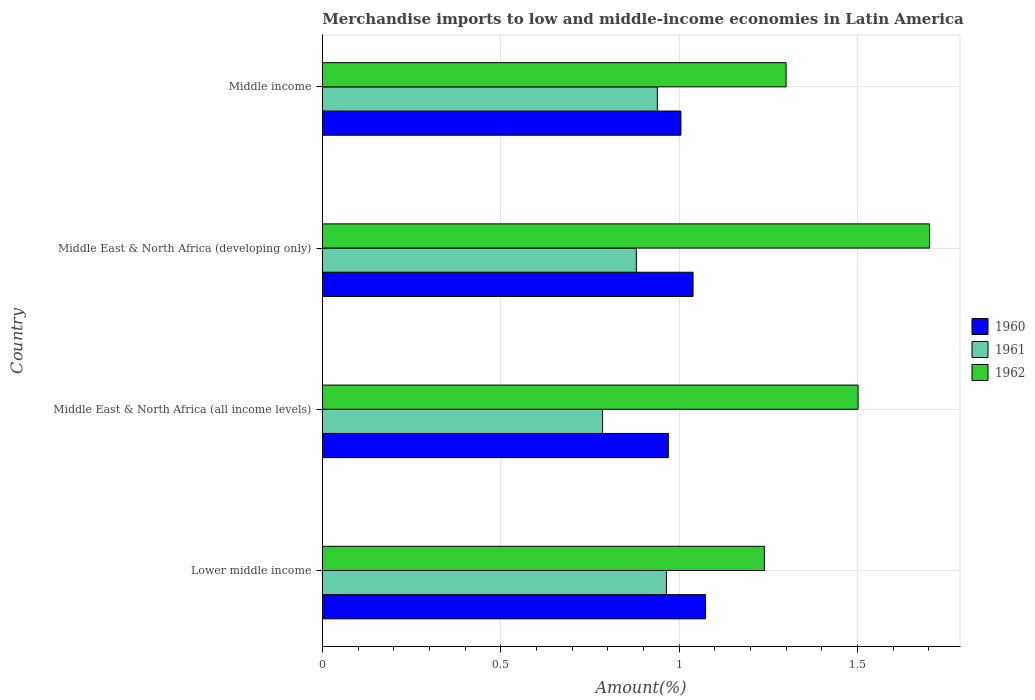Are the number of bars on each tick of the Y-axis equal?
Your answer should be compact. Yes. How many bars are there on the 2nd tick from the top?
Offer a terse response. 3. How many bars are there on the 1st tick from the bottom?
Offer a very short reply. 3. What is the label of the 4th group of bars from the top?
Keep it short and to the point. Lower middle income. What is the percentage of amount earned from merchandise imports in 1961 in Middle East & North Africa (developing only)?
Offer a very short reply. 0.88. Across all countries, what is the maximum percentage of amount earned from merchandise imports in 1960?
Your response must be concise. 1.07. Across all countries, what is the minimum percentage of amount earned from merchandise imports in 1962?
Give a very brief answer. 1.24. In which country was the percentage of amount earned from merchandise imports in 1962 maximum?
Provide a succinct answer. Middle East & North Africa (developing only). In which country was the percentage of amount earned from merchandise imports in 1960 minimum?
Your response must be concise. Middle East & North Africa (all income levels). What is the total percentage of amount earned from merchandise imports in 1961 in the graph?
Your answer should be very brief. 3.57. What is the difference between the percentage of amount earned from merchandise imports in 1960 in Middle East & North Africa (developing only) and that in Middle income?
Ensure brevity in your answer.  0.03. What is the difference between the percentage of amount earned from merchandise imports in 1961 in Middle income and the percentage of amount earned from merchandise imports in 1960 in Middle East & North Africa (developing only)?
Ensure brevity in your answer.  -0.1. What is the average percentage of amount earned from merchandise imports in 1961 per country?
Make the answer very short. 0.89. What is the difference between the percentage of amount earned from merchandise imports in 1961 and percentage of amount earned from merchandise imports in 1962 in Lower middle income?
Provide a short and direct response. -0.27. In how many countries, is the percentage of amount earned from merchandise imports in 1960 greater than 0.30000000000000004 %?
Your answer should be compact. 4. What is the ratio of the percentage of amount earned from merchandise imports in 1962 in Middle East & North Africa (developing only) to that in Middle income?
Keep it short and to the point. 1.31. Is the percentage of amount earned from merchandise imports in 1961 in Middle East & North Africa (all income levels) less than that in Middle income?
Offer a very short reply. Yes. What is the difference between the highest and the second highest percentage of amount earned from merchandise imports in 1961?
Your response must be concise. 0.03. What is the difference between the highest and the lowest percentage of amount earned from merchandise imports in 1960?
Provide a short and direct response. 0.1. In how many countries, is the percentage of amount earned from merchandise imports in 1960 greater than the average percentage of amount earned from merchandise imports in 1960 taken over all countries?
Keep it short and to the point. 2. Is the sum of the percentage of amount earned from merchandise imports in 1961 in Middle East & North Africa (developing only) and Middle income greater than the maximum percentage of amount earned from merchandise imports in 1962 across all countries?
Your response must be concise. Yes. Is it the case that in every country, the sum of the percentage of amount earned from merchandise imports in 1960 and percentage of amount earned from merchandise imports in 1961 is greater than the percentage of amount earned from merchandise imports in 1962?
Provide a succinct answer. Yes. How many bars are there?
Give a very brief answer. 12. Are all the bars in the graph horizontal?
Provide a short and direct response. Yes. How many countries are there in the graph?
Your answer should be very brief. 4. Are the values on the major ticks of X-axis written in scientific E-notation?
Ensure brevity in your answer.  No. Where does the legend appear in the graph?
Your response must be concise. Center right. How many legend labels are there?
Your answer should be very brief. 3. How are the legend labels stacked?
Offer a very short reply. Vertical. What is the title of the graph?
Your response must be concise. Merchandise imports to low and middle-income economies in Latin America. Does "1968" appear as one of the legend labels in the graph?
Provide a short and direct response. No. What is the label or title of the X-axis?
Your answer should be compact. Amount(%). What is the label or title of the Y-axis?
Offer a terse response. Country. What is the Amount(%) of 1960 in Lower middle income?
Your response must be concise. 1.07. What is the Amount(%) in 1961 in Lower middle income?
Provide a short and direct response. 0.96. What is the Amount(%) of 1962 in Lower middle income?
Offer a terse response. 1.24. What is the Amount(%) in 1960 in Middle East & North Africa (all income levels)?
Offer a terse response. 0.97. What is the Amount(%) in 1961 in Middle East & North Africa (all income levels)?
Your answer should be very brief. 0.79. What is the Amount(%) of 1962 in Middle East & North Africa (all income levels)?
Your response must be concise. 1.5. What is the Amount(%) of 1960 in Middle East & North Africa (developing only)?
Keep it short and to the point. 1.04. What is the Amount(%) of 1961 in Middle East & North Africa (developing only)?
Your answer should be very brief. 0.88. What is the Amount(%) of 1962 in Middle East & North Africa (developing only)?
Provide a short and direct response. 1.7. What is the Amount(%) of 1960 in Middle income?
Your response must be concise. 1.01. What is the Amount(%) in 1961 in Middle income?
Your response must be concise. 0.94. What is the Amount(%) of 1962 in Middle income?
Keep it short and to the point. 1.3. Across all countries, what is the maximum Amount(%) of 1960?
Your answer should be very brief. 1.07. Across all countries, what is the maximum Amount(%) in 1961?
Keep it short and to the point. 0.96. Across all countries, what is the maximum Amount(%) of 1962?
Your answer should be very brief. 1.7. Across all countries, what is the minimum Amount(%) of 1960?
Your answer should be very brief. 0.97. Across all countries, what is the minimum Amount(%) in 1961?
Provide a succinct answer. 0.79. Across all countries, what is the minimum Amount(%) of 1962?
Provide a succinct answer. 1.24. What is the total Amount(%) of 1960 in the graph?
Your response must be concise. 4.09. What is the total Amount(%) in 1961 in the graph?
Your answer should be very brief. 3.57. What is the total Amount(%) in 1962 in the graph?
Provide a succinct answer. 5.74. What is the difference between the Amount(%) in 1960 in Lower middle income and that in Middle East & North Africa (all income levels)?
Offer a very short reply. 0.1. What is the difference between the Amount(%) in 1961 in Lower middle income and that in Middle East & North Africa (all income levels)?
Your answer should be very brief. 0.18. What is the difference between the Amount(%) in 1962 in Lower middle income and that in Middle East & North Africa (all income levels)?
Your answer should be compact. -0.26. What is the difference between the Amount(%) of 1960 in Lower middle income and that in Middle East & North Africa (developing only)?
Your answer should be very brief. 0.04. What is the difference between the Amount(%) of 1961 in Lower middle income and that in Middle East & North Africa (developing only)?
Provide a succinct answer. 0.08. What is the difference between the Amount(%) of 1962 in Lower middle income and that in Middle East & North Africa (developing only)?
Provide a succinct answer. -0.46. What is the difference between the Amount(%) of 1960 in Lower middle income and that in Middle income?
Ensure brevity in your answer.  0.07. What is the difference between the Amount(%) in 1961 in Lower middle income and that in Middle income?
Ensure brevity in your answer.  0.03. What is the difference between the Amount(%) of 1962 in Lower middle income and that in Middle income?
Your response must be concise. -0.06. What is the difference between the Amount(%) of 1960 in Middle East & North Africa (all income levels) and that in Middle East & North Africa (developing only)?
Provide a succinct answer. -0.07. What is the difference between the Amount(%) in 1961 in Middle East & North Africa (all income levels) and that in Middle East & North Africa (developing only)?
Your answer should be compact. -0.09. What is the difference between the Amount(%) of 1962 in Middle East & North Africa (all income levels) and that in Middle East & North Africa (developing only)?
Make the answer very short. -0.2. What is the difference between the Amount(%) of 1960 in Middle East & North Africa (all income levels) and that in Middle income?
Your response must be concise. -0.04. What is the difference between the Amount(%) of 1961 in Middle East & North Africa (all income levels) and that in Middle income?
Ensure brevity in your answer.  -0.15. What is the difference between the Amount(%) in 1962 in Middle East & North Africa (all income levels) and that in Middle income?
Offer a terse response. 0.2. What is the difference between the Amount(%) in 1960 in Middle East & North Africa (developing only) and that in Middle income?
Offer a very short reply. 0.03. What is the difference between the Amount(%) of 1961 in Middle East & North Africa (developing only) and that in Middle income?
Provide a short and direct response. -0.06. What is the difference between the Amount(%) of 1962 in Middle East & North Africa (developing only) and that in Middle income?
Provide a short and direct response. 0.4. What is the difference between the Amount(%) of 1960 in Lower middle income and the Amount(%) of 1961 in Middle East & North Africa (all income levels)?
Offer a terse response. 0.29. What is the difference between the Amount(%) of 1960 in Lower middle income and the Amount(%) of 1962 in Middle East & North Africa (all income levels)?
Provide a succinct answer. -0.43. What is the difference between the Amount(%) in 1961 in Lower middle income and the Amount(%) in 1962 in Middle East & North Africa (all income levels)?
Your answer should be compact. -0.54. What is the difference between the Amount(%) of 1960 in Lower middle income and the Amount(%) of 1961 in Middle East & North Africa (developing only)?
Offer a terse response. 0.19. What is the difference between the Amount(%) of 1960 in Lower middle income and the Amount(%) of 1962 in Middle East & North Africa (developing only)?
Make the answer very short. -0.63. What is the difference between the Amount(%) of 1961 in Lower middle income and the Amount(%) of 1962 in Middle East & North Africa (developing only)?
Give a very brief answer. -0.74. What is the difference between the Amount(%) in 1960 in Lower middle income and the Amount(%) in 1961 in Middle income?
Make the answer very short. 0.14. What is the difference between the Amount(%) of 1960 in Lower middle income and the Amount(%) of 1962 in Middle income?
Provide a succinct answer. -0.23. What is the difference between the Amount(%) in 1961 in Lower middle income and the Amount(%) in 1962 in Middle income?
Your response must be concise. -0.34. What is the difference between the Amount(%) of 1960 in Middle East & North Africa (all income levels) and the Amount(%) of 1961 in Middle East & North Africa (developing only)?
Your response must be concise. 0.09. What is the difference between the Amount(%) of 1960 in Middle East & North Africa (all income levels) and the Amount(%) of 1962 in Middle East & North Africa (developing only)?
Provide a short and direct response. -0.73. What is the difference between the Amount(%) in 1961 in Middle East & North Africa (all income levels) and the Amount(%) in 1962 in Middle East & North Africa (developing only)?
Offer a very short reply. -0.92. What is the difference between the Amount(%) in 1960 in Middle East & North Africa (all income levels) and the Amount(%) in 1961 in Middle income?
Keep it short and to the point. 0.03. What is the difference between the Amount(%) in 1960 in Middle East & North Africa (all income levels) and the Amount(%) in 1962 in Middle income?
Make the answer very short. -0.33. What is the difference between the Amount(%) in 1961 in Middle East & North Africa (all income levels) and the Amount(%) in 1962 in Middle income?
Your answer should be compact. -0.51. What is the difference between the Amount(%) in 1960 in Middle East & North Africa (developing only) and the Amount(%) in 1961 in Middle income?
Your response must be concise. 0.1. What is the difference between the Amount(%) of 1960 in Middle East & North Africa (developing only) and the Amount(%) of 1962 in Middle income?
Offer a terse response. -0.26. What is the difference between the Amount(%) in 1961 in Middle East & North Africa (developing only) and the Amount(%) in 1962 in Middle income?
Your response must be concise. -0.42. What is the average Amount(%) in 1960 per country?
Keep it short and to the point. 1.02. What is the average Amount(%) of 1961 per country?
Make the answer very short. 0.89. What is the average Amount(%) of 1962 per country?
Make the answer very short. 1.44. What is the difference between the Amount(%) of 1960 and Amount(%) of 1961 in Lower middle income?
Your answer should be compact. 0.11. What is the difference between the Amount(%) of 1960 and Amount(%) of 1962 in Lower middle income?
Provide a succinct answer. -0.17. What is the difference between the Amount(%) of 1961 and Amount(%) of 1962 in Lower middle income?
Your answer should be very brief. -0.27. What is the difference between the Amount(%) in 1960 and Amount(%) in 1961 in Middle East & North Africa (all income levels)?
Offer a terse response. 0.18. What is the difference between the Amount(%) in 1960 and Amount(%) in 1962 in Middle East & North Africa (all income levels)?
Your response must be concise. -0.53. What is the difference between the Amount(%) of 1961 and Amount(%) of 1962 in Middle East & North Africa (all income levels)?
Provide a succinct answer. -0.72. What is the difference between the Amount(%) of 1960 and Amount(%) of 1961 in Middle East & North Africa (developing only)?
Keep it short and to the point. 0.16. What is the difference between the Amount(%) in 1960 and Amount(%) in 1962 in Middle East & North Africa (developing only)?
Your response must be concise. -0.66. What is the difference between the Amount(%) of 1961 and Amount(%) of 1962 in Middle East & North Africa (developing only)?
Make the answer very short. -0.82. What is the difference between the Amount(%) in 1960 and Amount(%) in 1961 in Middle income?
Ensure brevity in your answer.  0.07. What is the difference between the Amount(%) in 1960 and Amount(%) in 1962 in Middle income?
Your answer should be very brief. -0.29. What is the difference between the Amount(%) of 1961 and Amount(%) of 1962 in Middle income?
Provide a short and direct response. -0.36. What is the ratio of the Amount(%) in 1960 in Lower middle income to that in Middle East & North Africa (all income levels)?
Provide a short and direct response. 1.11. What is the ratio of the Amount(%) in 1961 in Lower middle income to that in Middle East & North Africa (all income levels)?
Your answer should be very brief. 1.23. What is the ratio of the Amount(%) of 1962 in Lower middle income to that in Middle East & North Africa (all income levels)?
Keep it short and to the point. 0.83. What is the ratio of the Amount(%) in 1960 in Lower middle income to that in Middle East & North Africa (developing only)?
Provide a short and direct response. 1.03. What is the ratio of the Amount(%) in 1961 in Lower middle income to that in Middle East & North Africa (developing only)?
Ensure brevity in your answer.  1.1. What is the ratio of the Amount(%) in 1962 in Lower middle income to that in Middle East & North Africa (developing only)?
Your answer should be compact. 0.73. What is the ratio of the Amount(%) of 1960 in Lower middle income to that in Middle income?
Your answer should be compact. 1.07. What is the ratio of the Amount(%) in 1961 in Lower middle income to that in Middle income?
Give a very brief answer. 1.03. What is the ratio of the Amount(%) of 1962 in Lower middle income to that in Middle income?
Give a very brief answer. 0.95. What is the ratio of the Amount(%) in 1960 in Middle East & North Africa (all income levels) to that in Middle East & North Africa (developing only)?
Ensure brevity in your answer.  0.93. What is the ratio of the Amount(%) of 1961 in Middle East & North Africa (all income levels) to that in Middle East & North Africa (developing only)?
Your answer should be very brief. 0.89. What is the ratio of the Amount(%) of 1962 in Middle East & North Africa (all income levels) to that in Middle East & North Africa (developing only)?
Your answer should be very brief. 0.88. What is the ratio of the Amount(%) in 1960 in Middle East & North Africa (all income levels) to that in Middle income?
Offer a very short reply. 0.96. What is the ratio of the Amount(%) of 1961 in Middle East & North Africa (all income levels) to that in Middle income?
Your answer should be compact. 0.84. What is the ratio of the Amount(%) in 1962 in Middle East & North Africa (all income levels) to that in Middle income?
Keep it short and to the point. 1.16. What is the ratio of the Amount(%) in 1960 in Middle East & North Africa (developing only) to that in Middle income?
Your response must be concise. 1.03. What is the ratio of the Amount(%) of 1961 in Middle East & North Africa (developing only) to that in Middle income?
Make the answer very short. 0.94. What is the ratio of the Amount(%) in 1962 in Middle East & North Africa (developing only) to that in Middle income?
Make the answer very short. 1.31. What is the difference between the highest and the second highest Amount(%) of 1960?
Make the answer very short. 0.04. What is the difference between the highest and the second highest Amount(%) in 1961?
Provide a succinct answer. 0.03. What is the difference between the highest and the second highest Amount(%) of 1962?
Ensure brevity in your answer.  0.2. What is the difference between the highest and the lowest Amount(%) in 1960?
Your answer should be very brief. 0.1. What is the difference between the highest and the lowest Amount(%) of 1961?
Ensure brevity in your answer.  0.18. What is the difference between the highest and the lowest Amount(%) of 1962?
Make the answer very short. 0.46. 